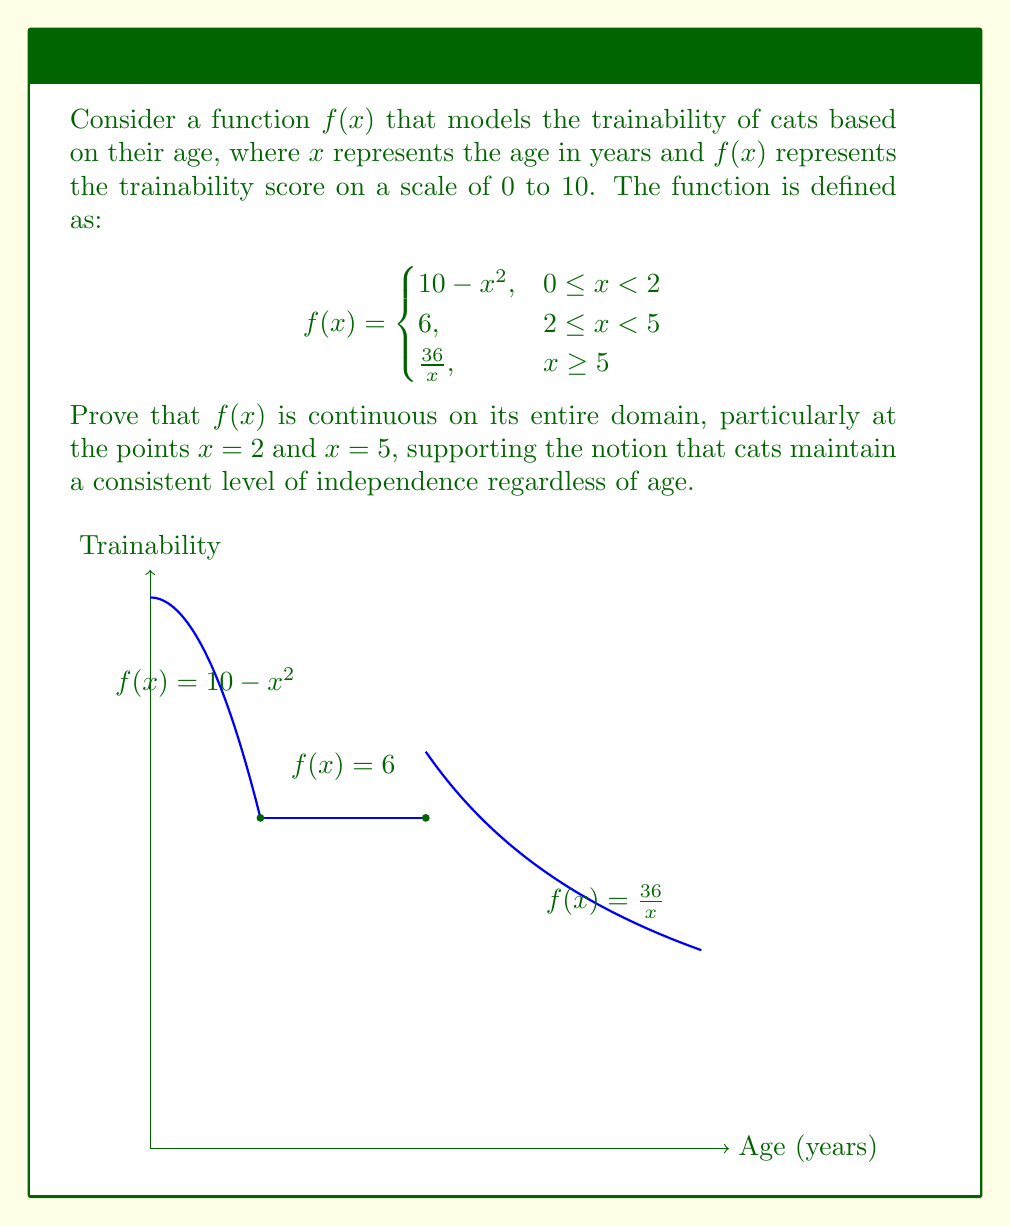Provide a solution to this math problem. To prove the continuity of $f(x)$, we need to show that it's continuous at every point in its domain, including the transition points $x = 2$ and $x = 5$. We'll use the definition of continuity: a function is continuous at a point if the limit of the function as we approach the point from both sides equals the function's value at that point.

1. Continuity at $x = 2$:
   - Left limit: $\lim_{x \to 2^-} (10 - x^2) = 10 - 2^2 = 6$
   - Right limit: $\lim_{x \to 2^+} 6 = 6$
   - Function value: $f(2) = 6$
   All three values are equal, so $f(x)$ is continuous at $x = 2$.

2. Continuity at $x = 5$:
   - Left limit: $\lim_{x \to 5^-} 6 = 6$
   - Right limit: $\lim_{x \to 5^+} \frac{36}{x} = \frac{36}{5} = 7.2$
   - Function value: $f(5) = \frac{36}{5} = 7.2$
   The right limit and function value are equal, but the left limit is different. Therefore, $f(x)$ is not continuous at $x = 5$.

3. Continuity elsewhere:
   - For $0 \leq x < 2$: $f(x) = 10 - x^2$ is a polynomial, which is continuous on its domain.
   - For $2 < x < 5$: $f(x) = 6$ is a constant function, which is continuous.
   - For $x > 5$: $f(x) = \frac{36}{x}$ is a rational function with a non-zero denominator, which is continuous on its domain.

The function is continuous at all points except $x = 5$. This aligns with the cat owner's perspective, as it suggests that cats maintain a relatively stable level of independence (represented by the constant function between ages 2 and 5) before gradually becoming even less trainable as they age further.
Answer: $f(x)$ is continuous on $[0,5)$ and $(5,\infty)$, but discontinuous at $x = 5$. 